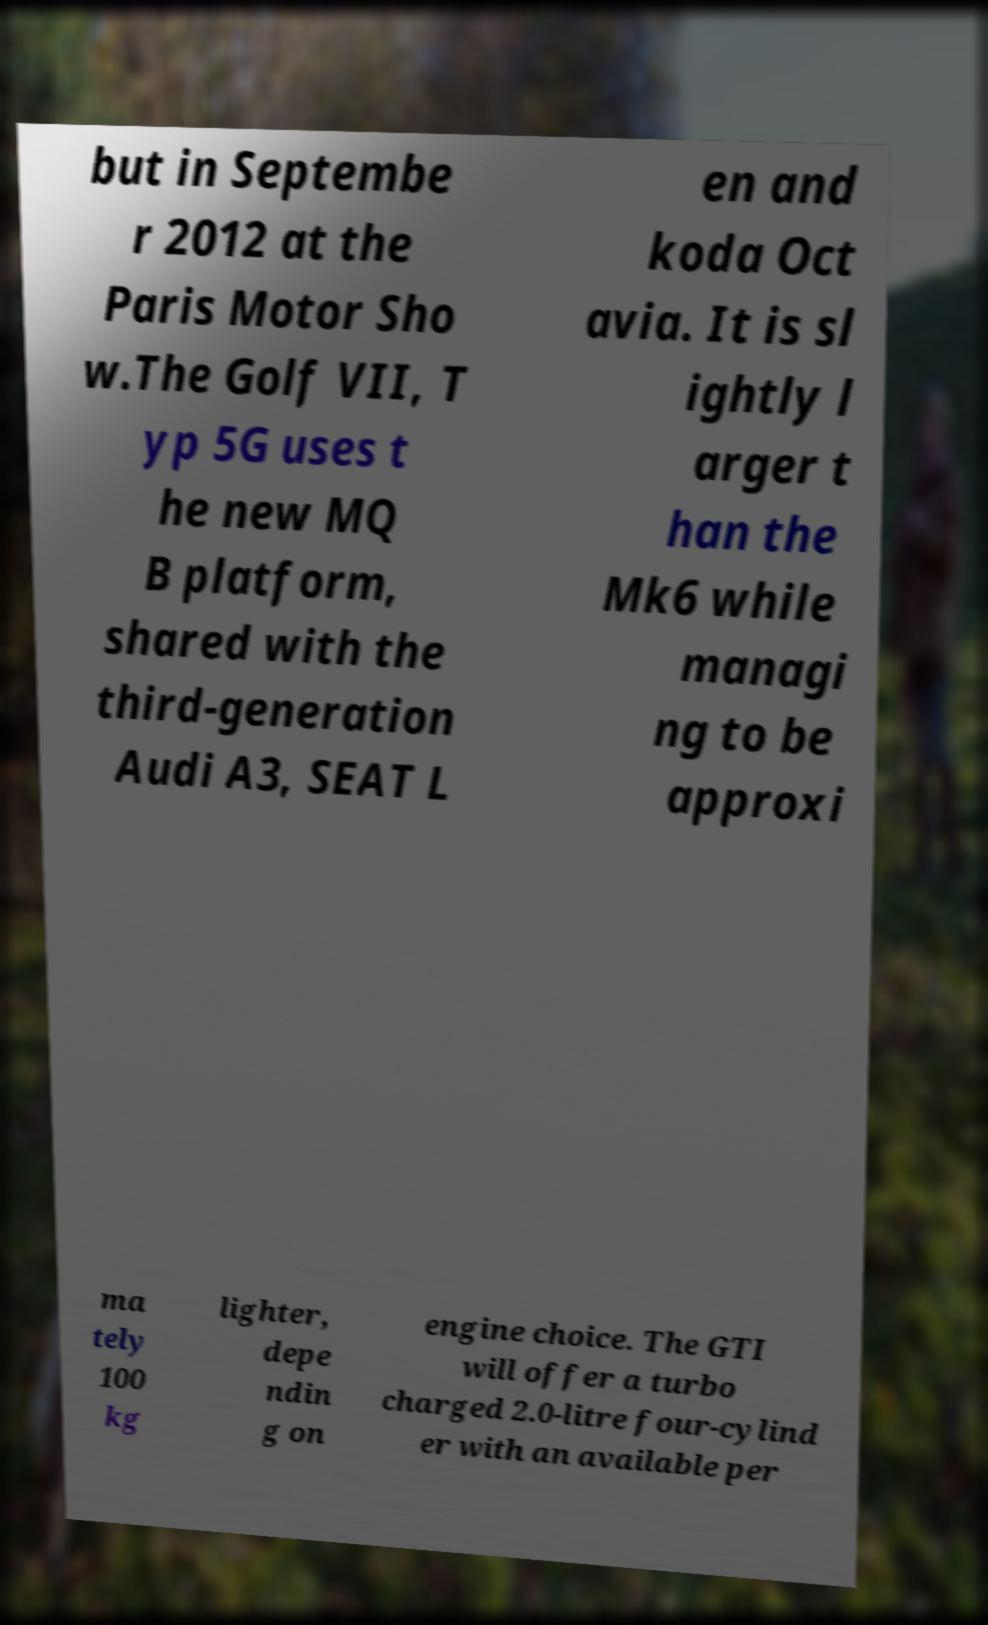Could you assist in decoding the text presented in this image and type it out clearly? but in Septembe r 2012 at the Paris Motor Sho w.The Golf VII, T yp 5G uses t he new MQ B platform, shared with the third-generation Audi A3, SEAT L en and koda Oct avia. It is sl ightly l arger t han the Mk6 while managi ng to be approxi ma tely 100 kg lighter, depe ndin g on engine choice. The GTI will offer a turbo charged 2.0-litre four-cylind er with an available per 